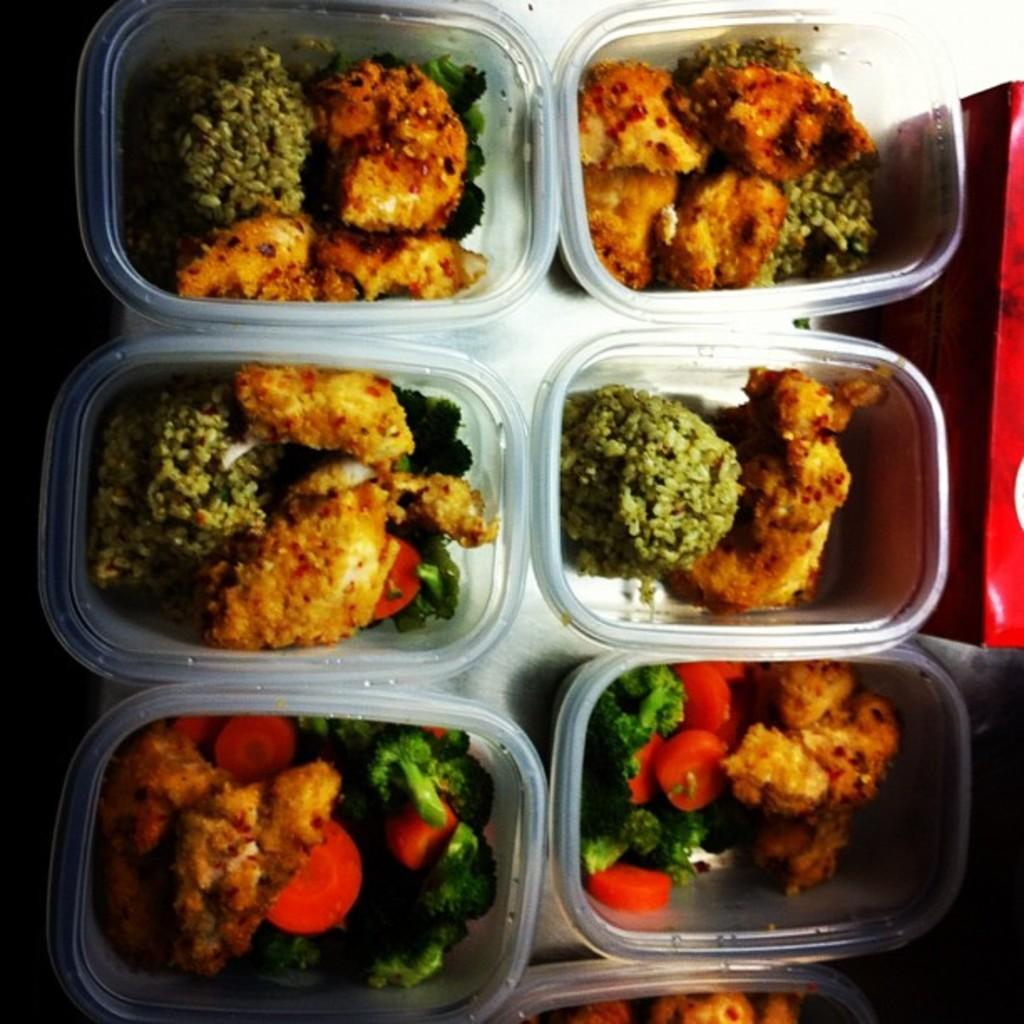What objects are present in the image that contain food items? There are bowls in the image that contain food items. What is the color of the box in the image? The box in the image is red. What type of cakes are being cast in the image? There are no cakes or casting activity present in the image. How many times is the ball being kicked in the image? There is no ball or kicking activity present in the image. 